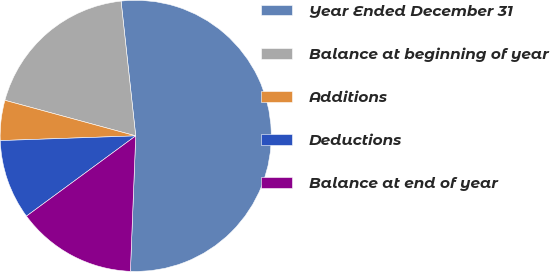<chart> <loc_0><loc_0><loc_500><loc_500><pie_chart><fcel>Year Ended December 31<fcel>Balance at beginning of year<fcel>Additions<fcel>Deductions<fcel>Balance at end of year<nl><fcel>52.35%<fcel>19.05%<fcel>4.78%<fcel>9.53%<fcel>14.29%<nl></chart> 